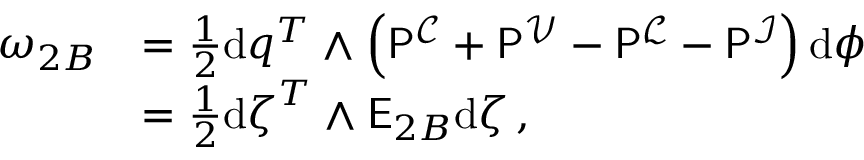<formula> <loc_0><loc_0><loc_500><loc_500>\begin{array} { r l } { \omega _ { 2 B } } & { = \frac { 1 } { 2 } d q ^ { T } \wedge \left ( P ^ { \mathcal { C } } + P ^ { \mathcal { V } } - P ^ { \mathcal { L } } - P ^ { \mathcal { I } } \right ) d \phi } \\ & { = \frac { 1 } { 2 } d \zeta ^ { T } \wedge E _ { 2 B } d \zeta \, , } \end{array}</formula> 